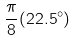Convert formula to latex. <formula><loc_0><loc_0><loc_500><loc_500>\frac { \pi } { 8 } ( 2 2 . 5 ^ { \circ } )</formula> 